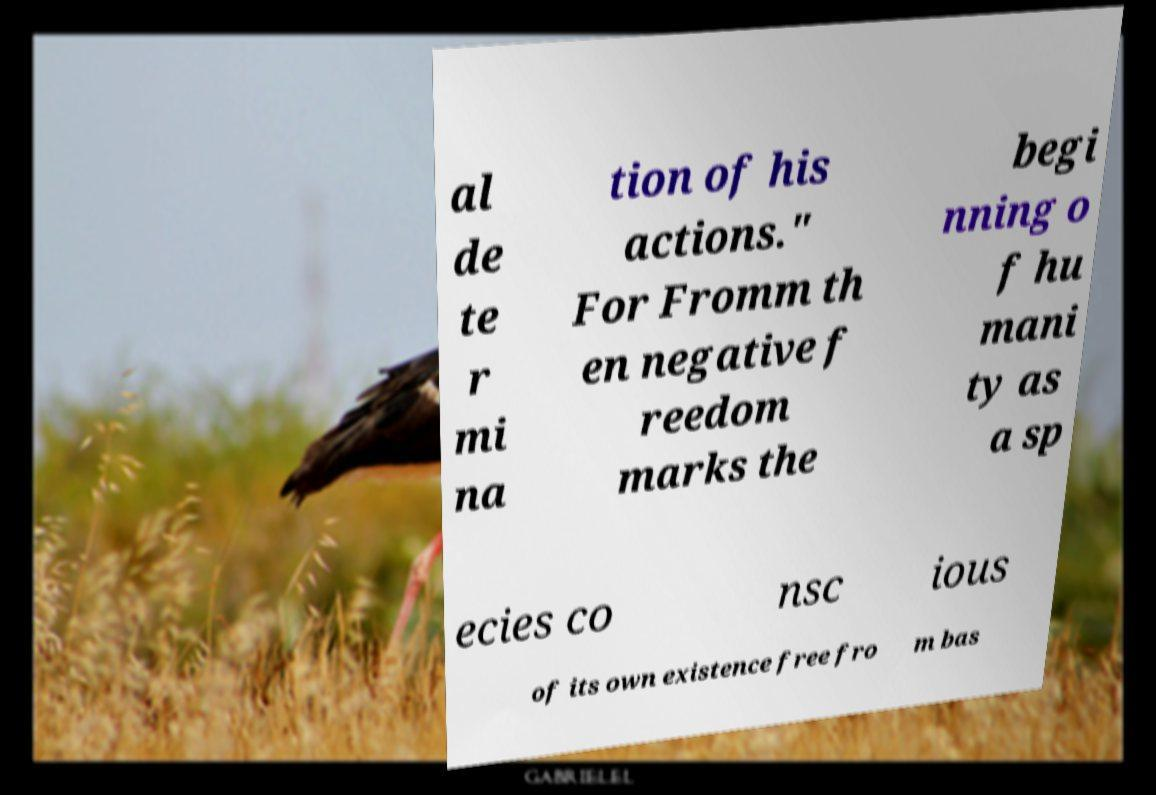There's text embedded in this image that I need extracted. Can you transcribe it verbatim? al de te r mi na tion of his actions." For Fromm th en negative f reedom marks the begi nning o f hu mani ty as a sp ecies co nsc ious of its own existence free fro m bas 